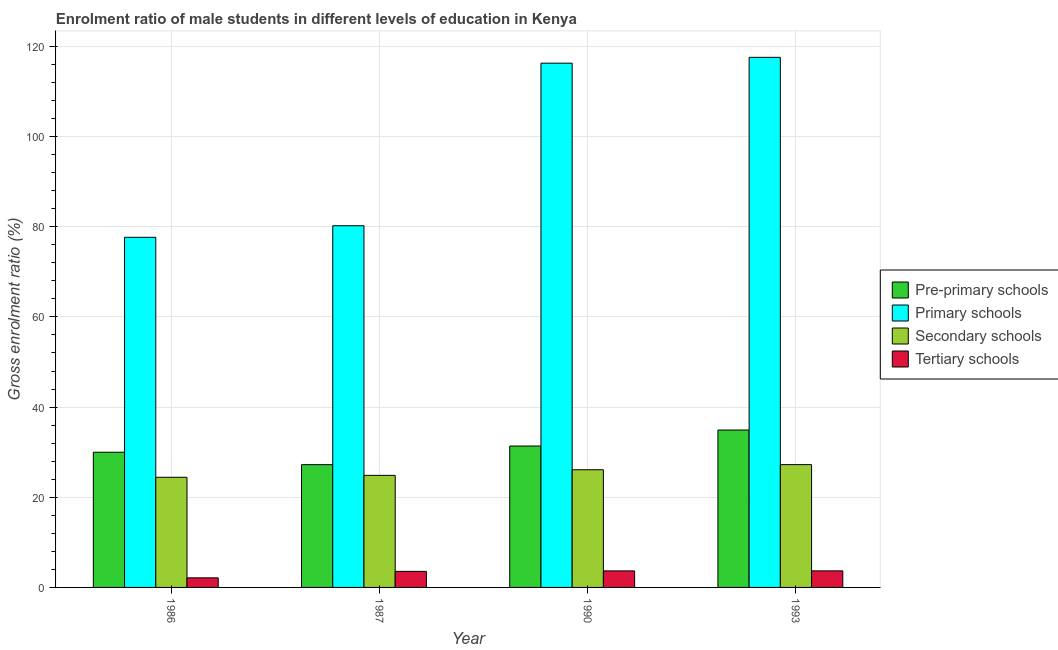How many different coloured bars are there?
Provide a succinct answer. 4. Are the number of bars on each tick of the X-axis equal?
Make the answer very short. Yes. How many bars are there on the 2nd tick from the left?
Offer a very short reply. 4. What is the label of the 3rd group of bars from the left?
Give a very brief answer. 1990. In how many cases, is the number of bars for a given year not equal to the number of legend labels?
Make the answer very short. 0. What is the gross enrolment ratio(female) in tertiary schools in 1987?
Your answer should be very brief. 3.56. Across all years, what is the maximum gross enrolment ratio(female) in secondary schools?
Your answer should be compact. 27.24. Across all years, what is the minimum gross enrolment ratio(female) in primary schools?
Offer a terse response. 77.66. In which year was the gross enrolment ratio(female) in primary schools minimum?
Offer a terse response. 1986. What is the total gross enrolment ratio(female) in pre-primary schools in the graph?
Provide a short and direct response. 123.5. What is the difference between the gross enrolment ratio(female) in primary schools in 1990 and that in 1993?
Provide a succinct answer. -1.29. What is the difference between the gross enrolment ratio(female) in tertiary schools in 1993 and the gross enrolment ratio(female) in pre-primary schools in 1987?
Offer a terse response. 0.11. What is the average gross enrolment ratio(female) in tertiary schools per year?
Provide a short and direct response. 3.26. In the year 1990, what is the difference between the gross enrolment ratio(female) in primary schools and gross enrolment ratio(female) in tertiary schools?
Provide a short and direct response. 0. In how many years, is the gross enrolment ratio(female) in pre-primary schools greater than 80 %?
Keep it short and to the point. 0. What is the ratio of the gross enrolment ratio(female) in pre-primary schools in 1990 to that in 1993?
Offer a very short reply. 0.9. Is the gross enrolment ratio(female) in primary schools in 1986 less than that in 1987?
Ensure brevity in your answer.  Yes. What is the difference between the highest and the second highest gross enrolment ratio(female) in secondary schools?
Offer a very short reply. 1.13. What is the difference between the highest and the lowest gross enrolment ratio(female) in tertiary schools?
Provide a short and direct response. 1.55. In how many years, is the gross enrolment ratio(female) in tertiary schools greater than the average gross enrolment ratio(female) in tertiary schools taken over all years?
Offer a very short reply. 3. Is the sum of the gross enrolment ratio(female) in secondary schools in 1990 and 1993 greater than the maximum gross enrolment ratio(female) in tertiary schools across all years?
Keep it short and to the point. Yes. What does the 1st bar from the left in 1990 represents?
Make the answer very short. Pre-primary schools. What does the 4th bar from the right in 1990 represents?
Your answer should be compact. Pre-primary schools. How many bars are there?
Give a very brief answer. 16. Are all the bars in the graph horizontal?
Offer a terse response. No. How many years are there in the graph?
Keep it short and to the point. 4. What is the difference between two consecutive major ticks on the Y-axis?
Provide a short and direct response. 20. Does the graph contain any zero values?
Offer a very short reply. No. What is the title of the graph?
Offer a terse response. Enrolment ratio of male students in different levels of education in Kenya. Does "Greece" appear as one of the legend labels in the graph?
Your answer should be compact. No. What is the label or title of the X-axis?
Ensure brevity in your answer.  Year. What is the label or title of the Y-axis?
Ensure brevity in your answer.  Gross enrolment ratio (%). What is the Gross enrolment ratio (%) in Pre-primary schools in 1986?
Your answer should be very brief. 29.99. What is the Gross enrolment ratio (%) in Primary schools in 1986?
Give a very brief answer. 77.66. What is the Gross enrolment ratio (%) of Secondary schools in 1986?
Your answer should be very brief. 24.43. What is the Gross enrolment ratio (%) of Tertiary schools in 1986?
Make the answer very short. 2.12. What is the Gross enrolment ratio (%) in Pre-primary schools in 1987?
Make the answer very short. 27.23. What is the Gross enrolment ratio (%) of Primary schools in 1987?
Provide a succinct answer. 80.23. What is the Gross enrolment ratio (%) of Secondary schools in 1987?
Make the answer very short. 24.86. What is the Gross enrolment ratio (%) of Tertiary schools in 1987?
Ensure brevity in your answer.  3.56. What is the Gross enrolment ratio (%) in Pre-primary schools in 1990?
Make the answer very short. 31.36. What is the Gross enrolment ratio (%) in Primary schools in 1990?
Offer a very short reply. 116.29. What is the Gross enrolment ratio (%) of Secondary schools in 1990?
Your answer should be compact. 26.11. What is the Gross enrolment ratio (%) in Tertiary schools in 1990?
Ensure brevity in your answer.  3.66. What is the Gross enrolment ratio (%) in Pre-primary schools in 1993?
Give a very brief answer. 34.91. What is the Gross enrolment ratio (%) of Primary schools in 1993?
Provide a short and direct response. 117.58. What is the Gross enrolment ratio (%) of Secondary schools in 1993?
Your response must be concise. 27.24. What is the Gross enrolment ratio (%) in Tertiary schools in 1993?
Make the answer very short. 3.67. Across all years, what is the maximum Gross enrolment ratio (%) in Pre-primary schools?
Your answer should be very brief. 34.91. Across all years, what is the maximum Gross enrolment ratio (%) in Primary schools?
Provide a succinct answer. 117.58. Across all years, what is the maximum Gross enrolment ratio (%) of Secondary schools?
Make the answer very short. 27.24. Across all years, what is the maximum Gross enrolment ratio (%) in Tertiary schools?
Your answer should be compact. 3.67. Across all years, what is the minimum Gross enrolment ratio (%) in Pre-primary schools?
Give a very brief answer. 27.23. Across all years, what is the minimum Gross enrolment ratio (%) in Primary schools?
Offer a very short reply. 77.66. Across all years, what is the minimum Gross enrolment ratio (%) of Secondary schools?
Your answer should be very brief. 24.43. Across all years, what is the minimum Gross enrolment ratio (%) in Tertiary schools?
Make the answer very short. 2.12. What is the total Gross enrolment ratio (%) of Pre-primary schools in the graph?
Offer a terse response. 123.5. What is the total Gross enrolment ratio (%) of Primary schools in the graph?
Your answer should be very brief. 391.76. What is the total Gross enrolment ratio (%) of Secondary schools in the graph?
Your answer should be very brief. 102.63. What is the total Gross enrolment ratio (%) of Tertiary schools in the graph?
Offer a very short reply. 13.02. What is the difference between the Gross enrolment ratio (%) in Pre-primary schools in 1986 and that in 1987?
Offer a terse response. 2.76. What is the difference between the Gross enrolment ratio (%) in Primary schools in 1986 and that in 1987?
Offer a terse response. -2.57. What is the difference between the Gross enrolment ratio (%) in Secondary schools in 1986 and that in 1987?
Your answer should be compact. -0.42. What is the difference between the Gross enrolment ratio (%) in Tertiary schools in 1986 and that in 1987?
Your answer should be compact. -1.44. What is the difference between the Gross enrolment ratio (%) in Pre-primary schools in 1986 and that in 1990?
Your answer should be very brief. -1.37. What is the difference between the Gross enrolment ratio (%) of Primary schools in 1986 and that in 1990?
Keep it short and to the point. -38.63. What is the difference between the Gross enrolment ratio (%) of Secondary schools in 1986 and that in 1990?
Provide a short and direct response. -1.67. What is the difference between the Gross enrolment ratio (%) of Tertiary schools in 1986 and that in 1990?
Your response must be concise. -1.54. What is the difference between the Gross enrolment ratio (%) in Pre-primary schools in 1986 and that in 1993?
Your answer should be very brief. -4.92. What is the difference between the Gross enrolment ratio (%) in Primary schools in 1986 and that in 1993?
Provide a short and direct response. -39.92. What is the difference between the Gross enrolment ratio (%) in Secondary schools in 1986 and that in 1993?
Your answer should be compact. -2.81. What is the difference between the Gross enrolment ratio (%) of Tertiary schools in 1986 and that in 1993?
Your answer should be compact. -1.55. What is the difference between the Gross enrolment ratio (%) in Pre-primary schools in 1987 and that in 1990?
Provide a succinct answer. -4.13. What is the difference between the Gross enrolment ratio (%) in Primary schools in 1987 and that in 1990?
Your response must be concise. -36.06. What is the difference between the Gross enrolment ratio (%) of Secondary schools in 1987 and that in 1990?
Offer a terse response. -1.25. What is the difference between the Gross enrolment ratio (%) in Tertiary schools in 1987 and that in 1990?
Your response must be concise. -0.1. What is the difference between the Gross enrolment ratio (%) in Pre-primary schools in 1987 and that in 1993?
Your answer should be compact. -7.68. What is the difference between the Gross enrolment ratio (%) in Primary schools in 1987 and that in 1993?
Your answer should be very brief. -37.35. What is the difference between the Gross enrolment ratio (%) in Secondary schools in 1987 and that in 1993?
Give a very brief answer. -2.38. What is the difference between the Gross enrolment ratio (%) of Tertiary schools in 1987 and that in 1993?
Your answer should be compact. -0.11. What is the difference between the Gross enrolment ratio (%) in Pre-primary schools in 1990 and that in 1993?
Ensure brevity in your answer.  -3.55. What is the difference between the Gross enrolment ratio (%) of Primary schools in 1990 and that in 1993?
Offer a terse response. -1.29. What is the difference between the Gross enrolment ratio (%) in Secondary schools in 1990 and that in 1993?
Your answer should be compact. -1.13. What is the difference between the Gross enrolment ratio (%) in Tertiary schools in 1990 and that in 1993?
Provide a short and direct response. -0.01. What is the difference between the Gross enrolment ratio (%) of Pre-primary schools in 1986 and the Gross enrolment ratio (%) of Primary schools in 1987?
Ensure brevity in your answer.  -50.24. What is the difference between the Gross enrolment ratio (%) of Pre-primary schools in 1986 and the Gross enrolment ratio (%) of Secondary schools in 1987?
Make the answer very short. 5.13. What is the difference between the Gross enrolment ratio (%) of Pre-primary schools in 1986 and the Gross enrolment ratio (%) of Tertiary schools in 1987?
Provide a short and direct response. 26.43. What is the difference between the Gross enrolment ratio (%) in Primary schools in 1986 and the Gross enrolment ratio (%) in Secondary schools in 1987?
Your response must be concise. 52.8. What is the difference between the Gross enrolment ratio (%) of Primary schools in 1986 and the Gross enrolment ratio (%) of Tertiary schools in 1987?
Ensure brevity in your answer.  74.1. What is the difference between the Gross enrolment ratio (%) in Secondary schools in 1986 and the Gross enrolment ratio (%) in Tertiary schools in 1987?
Give a very brief answer. 20.87. What is the difference between the Gross enrolment ratio (%) in Pre-primary schools in 1986 and the Gross enrolment ratio (%) in Primary schools in 1990?
Keep it short and to the point. -86.3. What is the difference between the Gross enrolment ratio (%) in Pre-primary schools in 1986 and the Gross enrolment ratio (%) in Secondary schools in 1990?
Your answer should be very brief. 3.89. What is the difference between the Gross enrolment ratio (%) of Pre-primary schools in 1986 and the Gross enrolment ratio (%) of Tertiary schools in 1990?
Keep it short and to the point. 26.33. What is the difference between the Gross enrolment ratio (%) of Primary schools in 1986 and the Gross enrolment ratio (%) of Secondary schools in 1990?
Provide a succinct answer. 51.55. What is the difference between the Gross enrolment ratio (%) of Primary schools in 1986 and the Gross enrolment ratio (%) of Tertiary schools in 1990?
Your answer should be compact. 74. What is the difference between the Gross enrolment ratio (%) of Secondary schools in 1986 and the Gross enrolment ratio (%) of Tertiary schools in 1990?
Provide a succinct answer. 20.77. What is the difference between the Gross enrolment ratio (%) in Pre-primary schools in 1986 and the Gross enrolment ratio (%) in Primary schools in 1993?
Ensure brevity in your answer.  -87.59. What is the difference between the Gross enrolment ratio (%) of Pre-primary schools in 1986 and the Gross enrolment ratio (%) of Secondary schools in 1993?
Provide a short and direct response. 2.75. What is the difference between the Gross enrolment ratio (%) in Pre-primary schools in 1986 and the Gross enrolment ratio (%) in Tertiary schools in 1993?
Your answer should be very brief. 26.32. What is the difference between the Gross enrolment ratio (%) in Primary schools in 1986 and the Gross enrolment ratio (%) in Secondary schools in 1993?
Your answer should be compact. 50.42. What is the difference between the Gross enrolment ratio (%) of Primary schools in 1986 and the Gross enrolment ratio (%) of Tertiary schools in 1993?
Offer a very short reply. 73.99. What is the difference between the Gross enrolment ratio (%) in Secondary schools in 1986 and the Gross enrolment ratio (%) in Tertiary schools in 1993?
Ensure brevity in your answer.  20.76. What is the difference between the Gross enrolment ratio (%) in Pre-primary schools in 1987 and the Gross enrolment ratio (%) in Primary schools in 1990?
Provide a short and direct response. -89.05. What is the difference between the Gross enrolment ratio (%) in Pre-primary schools in 1987 and the Gross enrolment ratio (%) in Secondary schools in 1990?
Offer a very short reply. 1.13. What is the difference between the Gross enrolment ratio (%) of Pre-primary schools in 1987 and the Gross enrolment ratio (%) of Tertiary schools in 1990?
Your answer should be compact. 23.57. What is the difference between the Gross enrolment ratio (%) in Primary schools in 1987 and the Gross enrolment ratio (%) in Secondary schools in 1990?
Ensure brevity in your answer.  54.13. What is the difference between the Gross enrolment ratio (%) of Primary schools in 1987 and the Gross enrolment ratio (%) of Tertiary schools in 1990?
Provide a short and direct response. 76.57. What is the difference between the Gross enrolment ratio (%) in Secondary schools in 1987 and the Gross enrolment ratio (%) in Tertiary schools in 1990?
Ensure brevity in your answer.  21.19. What is the difference between the Gross enrolment ratio (%) in Pre-primary schools in 1987 and the Gross enrolment ratio (%) in Primary schools in 1993?
Your response must be concise. -90.35. What is the difference between the Gross enrolment ratio (%) in Pre-primary schools in 1987 and the Gross enrolment ratio (%) in Secondary schools in 1993?
Your answer should be very brief. -0.01. What is the difference between the Gross enrolment ratio (%) in Pre-primary schools in 1987 and the Gross enrolment ratio (%) in Tertiary schools in 1993?
Your response must be concise. 23.56. What is the difference between the Gross enrolment ratio (%) in Primary schools in 1987 and the Gross enrolment ratio (%) in Secondary schools in 1993?
Ensure brevity in your answer.  52.99. What is the difference between the Gross enrolment ratio (%) of Primary schools in 1987 and the Gross enrolment ratio (%) of Tertiary schools in 1993?
Your answer should be compact. 76.56. What is the difference between the Gross enrolment ratio (%) in Secondary schools in 1987 and the Gross enrolment ratio (%) in Tertiary schools in 1993?
Offer a very short reply. 21.18. What is the difference between the Gross enrolment ratio (%) in Pre-primary schools in 1990 and the Gross enrolment ratio (%) in Primary schools in 1993?
Your response must be concise. -86.22. What is the difference between the Gross enrolment ratio (%) of Pre-primary schools in 1990 and the Gross enrolment ratio (%) of Secondary schools in 1993?
Ensure brevity in your answer.  4.12. What is the difference between the Gross enrolment ratio (%) of Pre-primary schools in 1990 and the Gross enrolment ratio (%) of Tertiary schools in 1993?
Offer a terse response. 27.69. What is the difference between the Gross enrolment ratio (%) in Primary schools in 1990 and the Gross enrolment ratio (%) in Secondary schools in 1993?
Your answer should be compact. 89.05. What is the difference between the Gross enrolment ratio (%) in Primary schools in 1990 and the Gross enrolment ratio (%) in Tertiary schools in 1993?
Ensure brevity in your answer.  112.62. What is the difference between the Gross enrolment ratio (%) in Secondary schools in 1990 and the Gross enrolment ratio (%) in Tertiary schools in 1993?
Offer a terse response. 22.43. What is the average Gross enrolment ratio (%) in Pre-primary schools per year?
Keep it short and to the point. 30.88. What is the average Gross enrolment ratio (%) of Primary schools per year?
Give a very brief answer. 97.94. What is the average Gross enrolment ratio (%) in Secondary schools per year?
Ensure brevity in your answer.  25.66. What is the average Gross enrolment ratio (%) of Tertiary schools per year?
Offer a very short reply. 3.26. In the year 1986, what is the difference between the Gross enrolment ratio (%) in Pre-primary schools and Gross enrolment ratio (%) in Primary schools?
Your answer should be compact. -47.67. In the year 1986, what is the difference between the Gross enrolment ratio (%) of Pre-primary schools and Gross enrolment ratio (%) of Secondary schools?
Provide a succinct answer. 5.56. In the year 1986, what is the difference between the Gross enrolment ratio (%) of Pre-primary schools and Gross enrolment ratio (%) of Tertiary schools?
Your answer should be very brief. 27.87. In the year 1986, what is the difference between the Gross enrolment ratio (%) in Primary schools and Gross enrolment ratio (%) in Secondary schools?
Your response must be concise. 53.23. In the year 1986, what is the difference between the Gross enrolment ratio (%) in Primary schools and Gross enrolment ratio (%) in Tertiary schools?
Ensure brevity in your answer.  75.54. In the year 1986, what is the difference between the Gross enrolment ratio (%) of Secondary schools and Gross enrolment ratio (%) of Tertiary schools?
Provide a short and direct response. 22.31. In the year 1987, what is the difference between the Gross enrolment ratio (%) of Pre-primary schools and Gross enrolment ratio (%) of Primary schools?
Your answer should be very brief. -53. In the year 1987, what is the difference between the Gross enrolment ratio (%) in Pre-primary schools and Gross enrolment ratio (%) in Secondary schools?
Your response must be concise. 2.38. In the year 1987, what is the difference between the Gross enrolment ratio (%) of Pre-primary schools and Gross enrolment ratio (%) of Tertiary schools?
Offer a very short reply. 23.67. In the year 1987, what is the difference between the Gross enrolment ratio (%) of Primary schools and Gross enrolment ratio (%) of Secondary schools?
Your response must be concise. 55.38. In the year 1987, what is the difference between the Gross enrolment ratio (%) of Primary schools and Gross enrolment ratio (%) of Tertiary schools?
Ensure brevity in your answer.  76.67. In the year 1987, what is the difference between the Gross enrolment ratio (%) in Secondary schools and Gross enrolment ratio (%) in Tertiary schools?
Your response must be concise. 21.29. In the year 1990, what is the difference between the Gross enrolment ratio (%) in Pre-primary schools and Gross enrolment ratio (%) in Primary schools?
Ensure brevity in your answer.  -84.92. In the year 1990, what is the difference between the Gross enrolment ratio (%) in Pre-primary schools and Gross enrolment ratio (%) in Secondary schools?
Offer a terse response. 5.26. In the year 1990, what is the difference between the Gross enrolment ratio (%) in Pre-primary schools and Gross enrolment ratio (%) in Tertiary schools?
Offer a very short reply. 27.7. In the year 1990, what is the difference between the Gross enrolment ratio (%) in Primary schools and Gross enrolment ratio (%) in Secondary schools?
Your response must be concise. 90.18. In the year 1990, what is the difference between the Gross enrolment ratio (%) in Primary schools and Gross enrolment ratio (%) in Tertiary schools?
Give a very brief answer. 112.62. In the year 1990, what is the difference between the Gross enrolment ratio (%) in Secondary schools and Gross enrolment ratio (%) in Tertiary schools?
Make the answer very short. 22.44. In the year 1993, what is the difference between the Gross enrolment ratio (%) of Pre-primary schools and Gross enrolment ratio (%) of Primary schools?
Offer a very short reply. -82.67. In the year 1993, what is the difference between the Gross enrolment ratio (%) of Pre-primary schools and Gross enrolment ratio (%) of Secondary schools?
Make the answer very short. 7.67. In the year 1993, what is the difference between the Gross enrolment ratio (%) of Pre-primary schools and Gross enrolment ratio (%) of Tertiary schools?
Make the answer very short. 31.24. In the year 1993, what is the difference between the Gross enrolment ratio (%) in Primary schools and Gross enrolment ratio (%) in Secondary schools?
Ensure brevity in your answer.  90.34. In the year 1993, what is the difference between the Gross enrolment ratio (%) of Primary schools and Gross enrolment ratio (%) of Tertiary schools?
Make the answer very short. 113.91. In the year 1993, what is the difference between the Gross enrolment ratio (%) of Secondary schools and Gross enrolment ratio (%) of Tertiary schools?
Make the answer very short. 23.57. What is the ratio of the Gross enrolment ratio (%) of Pre-primary schools in 1986 to that in 1987?
Your response must be concise. 1.1. What is the ratio of the Gross enrolment ratio (%) of Tertiary schools in 1986 to that in 1987?
Make the answer very short. 0.6. What is the ratio of the Gross enrolment ratio (%) in Pre-primary schools in 1986 to that in 1990?
Make the answer very short. 0.96. What is the ratio of the Gross enrolment ratio (%) of Primary schools in 1986 to that in 1990?
Keep it short and to the point. 0.67. What is the ratio of the Gross enrolment ratio (%) in Secondary schools in 1986 to that in 1990?
Keep it short and to the point. 0.94. What is the ratio of the Gross enrolment ratio (%) in Tertiary schools in 1986 to that in 1990?
Your answer should be very brief. 0.58. What is the ratio of the Gross enrolment ratio (%) of Pre-primary schools in 1986 to that in 1993?
Your answer should be very brief. 0.86. What is the ratio of the Gross enrolment ratio (%) in Primary schools in 1986 to that in 1993?
Your response must be concise. 0.66. What is the ratio of the Gross enrolment ratio (%) of Secondary schools in 1986 to that in 1993?
Make the answer very short. 0.9. What is the ratio of the Gross enrolment ratio (%) of Tertiary schools in 1986 to that in 1993?
Your answer should be compact. 0.58. What is the ratio of the Gross enrolment ratio (%) of Pre-primary schools in 1987 to that in 1990?
Provide a succinct answer. 0.87. What is the ratio of the Gross enrolment ratio (%) in Primary schools in 1987 to that in 1990?
Provide a short and direct response. 0.69. What is the ratio of the Gross enrolment ratio (%) of Secondary schools in 1987 to that in 1990?
Give a very brief answer. 0.95. What is the ratio of the Gross enrolment ratio (%) of Tertiary schools in 1987 to that in 1990?
Provide a succinct answer. 0.97. What is the ratio of the Gross enrolment ratio (%) of Pre-primary schools in 1987 to that in 1993?
Keep it short and to the point. 0.78. What is the ratio of the Gross enrolment ratio (%) of Primary schools in 1987 to that in 1993?
Provide a short and direct response. 0.68. What is the ratio of the Gross enrolment ratio (%) in Secondary schools in 1987 to that in 1993?
Give a very brief answer. 0.91. What is the ratio of the Gross enrolment ratio (%) of Tertiary schools in 1987 to that in 1993?
Keep it short and to the point. 0.97. What is the ratio of the Gross enrolment ratio (%) of Pre-primary schools in 1990 to that in 1993?
Offer a terse response. 0.9. What is the difference between the highest and the second highest Gross enrolment ratio (%) of Pre-primary schools?
Make the answer very short. 3.55. What is the difference between the highest and the second highest Gross enrolment ratio (%) in Primary schools?
Ensure brevity in your answer.  1.29. What is the difference between the highest and the second highest Gross enrolment ratio (%) in Secondary schools?
Make the answer very short. 1.13. What is the difference between the highest and the second highest Gross enrolment ratio (%) in Tertiary schools?
Your answer should be compact. 0.01. What is the difference between the highest and the lowest Gross enrolment ratio (%) of Pre-primary schools?
Give a very brief answer. 7.68. What is the difference between the highest and the lowest Gross enrolment ratio (%) in Primary schools?
Keep it short and to the point. 39.92. What is the difference between the highest and the lowest Gross enrolment ratio (%) in Secondary schools?
Give a very brief answer. 2.81. What is the difference between the highest and the lowest Gross enrolment ratio (%) of Tertiary schools?
Your response must be concise. 1.55. 